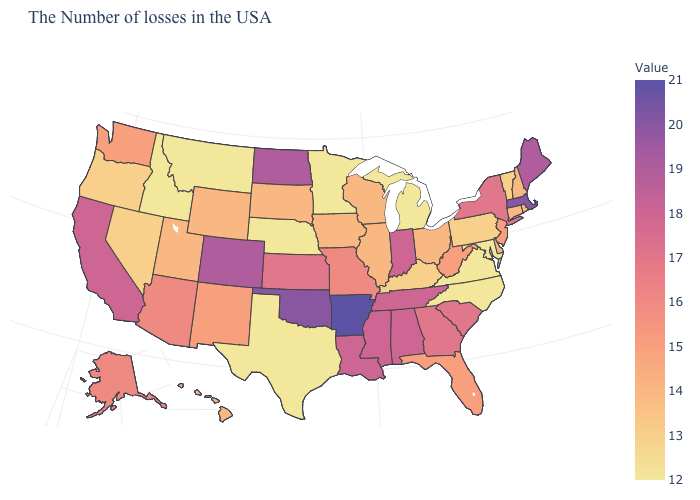Does Arkansas have the highest value in the South?
Concise answer only. Yes. 